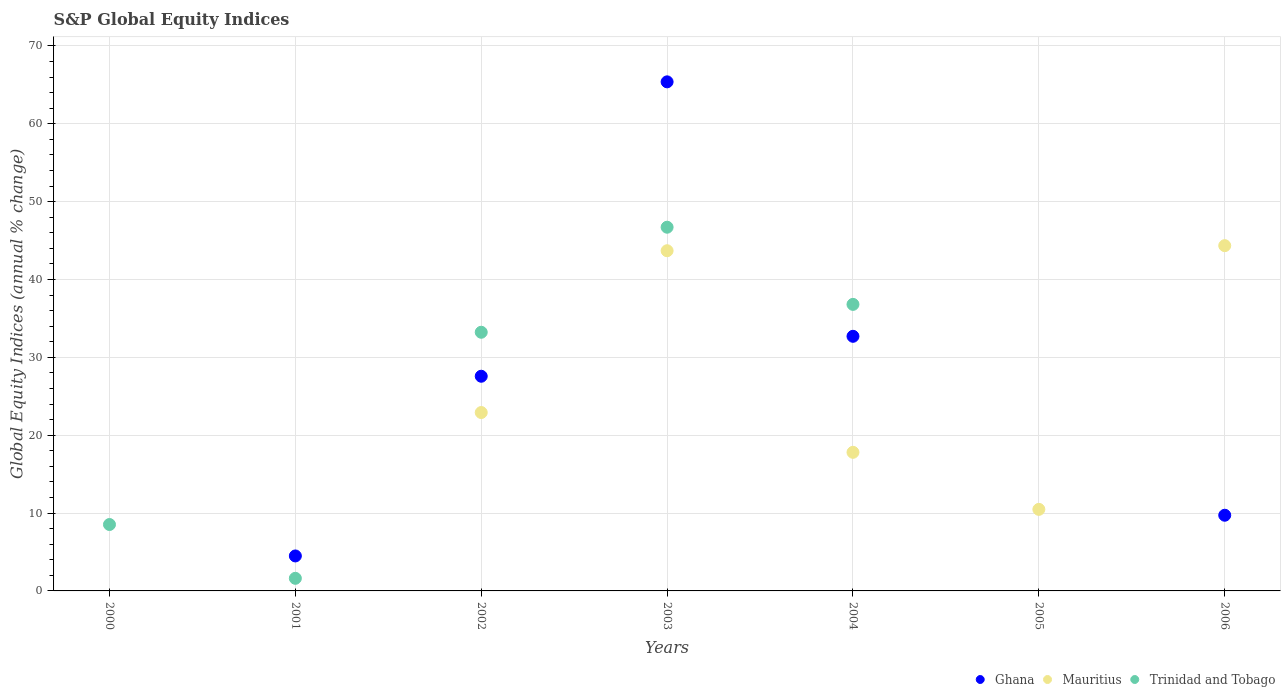Is the number of dotlines equal to the number of legend labels?
Provide a succinct answer. No. What is the global equity indices in Mauritius in 2005?
Give a very brief answer. 10.47. Across all years, what is the maximum global equity indices in Trinidad and Tobago?
Keep it short and to the point. 46.71. What is the total global equity indices in Mauritius in the graph?
Offer a terse response. 139.22. What is the difference between the global equity indices in Ghana in 2004 and that in 2006?
Offer a terse response. 22.98. What is the difference between the global equity indices in Ghana in 2003 and the global equity indices in Mauritius in 2000?
Give a very brief answer. 65.38. What is the average global equity indices in Ghana per year?
Ensure brevity in your answer.  19.98. In the year 2004, what is the difference between the global equity indices in Ghana and global equity indices in Mauritius?
Your answer should be compact. 14.9. In how many years, is the global equity indices in Trinidad and Tobago greater than 52 %?
Offer a very short reply. 0. What is the ratio of the global equity indices in Ghana in 2004 to that in 2006?
Your answer should be compact. 3.36. Is the global equity indices in Ghana in 2002 less than that in 2003?
Your answer should be very brief. Yes. What is the difference between the highest and the second highest global equity indices in Ghana?
Ensure brevity in your answer.  32.68. What is the difference between the highest and the lowest global equity indices in Mauritius?
Provide a succinct answer. 44.34. In how many years, is the global equity indices in Trinidad and Tobago greater than the average global equity indices in Trinidad and Tobago taken over all years?
Make the answer very short. 3. Is the global equity indices in Ghana strictly less than the global equity indices in Trinidad and Tobago over the years?
Provide a succinct answer. No. How many dotlines are there?
Keep it short and to the point. 3. How many years are there in the graph?
Your response must be concise. 7. Does the graph contain any zero values?
Provide a short and direct response. Yes. Does the graph contain grids?
Your answer should be very brief. Yes. Where does the legend appear in the graph?
Your answer should be compact. Bottom right. How many legend labels are there?
Keep it short and to the point. 3. What is the title of the graph?
Ensure brevity in your answer.  S&P Global Equity Indices. Does "Bosnia and Herzegovina" appear as one of the legend labels in the graph?
Your response must be concise. No. What is the label or title of the X-axis?
Ensure brevity in your answer.  Years. What is the label or title of the Y-axis?
Your answer should be compact. Global Equity Indices (annual % change). What is the Global Equity Indices (annual % change) of Ghana in 2000?
Your answer should be very brief. 0. What is the Global Equity Indices (annual % change) in Trinidad and Tobago in 2000?
Provide a short and direct response. 8.53. What is the Global Equity Indices (annual % change) of Ghana in 2001?
Keep it short and to the point. 4.49. What is the Global Equity Indices (annual % change) of Trinidad and Tobago in 2001?
Make the answer very short. 1.62. What is the Global Equity Indices (annual % change) in Ghana in 2002?
Give a very brief answer. 27.57. What is the Global Equity Indices (annual % change) in Mauritius in 2002?
Give a very brief answer. 22.91. What is the Global Equity Indices (annual % change) in Trinidad and Tobago in 2002?
Offer a terse response. 33.22. What is the Global Equity Indices (annual % change) of Ghana in 2003?
Provide a short and direct response. 65.38. What is the Global Equity Indices (annual % change) in Mauritius in 2003?
Offer a terse response. 43.69. What is the Global Equity Indices (annual % change) in Trinidad and Tobago in 2003?
Offer a very short reply. 46.71. What is the Global Equity Indices (annual % change) in Ghana in 2004?
Your answer should be very brief. 32.7. What is the Global Equity Indices (annual % change) in Mauritius in 2004?
Your answer should be very brief. 17.8. What is the Global Equity Indices (annual % change) in Trinidad and Tobago in 2004?
Provide a succinct answer. 36.8. What is the Global Equity Indices (annual % change) in Mauritius in 2005?
Ensure brevity in your answer.  10.47. What is the Global Equity Indices (annual % change) in Ghana in 2006?
Give a very brief answer. 9.72. What is the Global Equity Indices (annual % change) of Mauritius in 2006?
Offer a terse response. 44.34. What is the Global Equity Indices (annual % change) in Trinidad and Tobago in 2006?
Keep it short and to the point. 0. Across all years, what is the maximum Global Equity Indices (annual % change) in Ghana?
Your answer should be compact. 65.38. Across all years, what is the maximum Global Equity Indices (annual % change) in Mauritius?
Provide a short and direct response. 44.34. Across all years, what is the maximum Global Equity Indices (annual % change) in Trinidad and Tobago?
Your answer should be very brief. 46.71. Across all years, what is the minimum Global Equity Indices (annual % change) of Ghana?
Your answer should be very brief. 0. What is the total Global Equity Indices (annual % change) of Ghana in the graph?
Your answer should be very brief. 139.86. What is the total Global Equity Indices (annual % change) of Mauritius in the graph?
Offer a terse response. 139.22. What is the total Global Equity Indices (annual % change) in Trinidad and Tobago in the graph?
Your answer should be very brief. 126.88. What is the difference between the Global Equity Indices (annual % change) of Trinidad and Tobago in 2000 and that in 2001?
Give a very brief answer. 6.91. What is the difference between the Global Equity Indices (annual % change) in Trinidad and Tobago in 2000 and that in 2002?
Make the answer very short. -24.69. What is the difference between the Global Equity Indices (annual % change) in Trinidad and Tobago in 2000 and that in 2003?
Keep it short and to the point. -38.18. What is the difference between the Global Equity Indices (annual % change) in Trinidad and Tobago in 2000 and that in 2004?
Give a very brief answer. -28.27. What is the difference between the Global Equity Indices (annual % change) of Ghana in 2001 and that in 2002?
Ensure brevity in your answer.  -23.08. What is the difference between the Global Equity Indices (annual % change) of Trinidad and Tobago in 2001 and that in 2002?
Offer a terse response. -31.6. What is the difference between the Global Equity Indices (annual % change) of Ghana in 2001 and that in 2003?
Give a very brief answer. -60.89. What is the difference between the Global Equity Indices (annual % change) in Trinidad and Tobago in 2001 and that in 2003?
Offer a terse response. -45.09. What is the difference between the Global Equity Indices (annual % change) of Ghana in 2001 and that in 2004?
Ensure brevity in your answer.  -28.21. What is the difference between the Global Equity Indices (annual % change) in Trinidad and Tobago in 2001 and that in 2004?
Your answer should be compact. -35.18. What is the difference between the Global Equity Indices (annual % change) in Ghana in 2001 and that in 2006?
Offer a very short reply. -5.23. What is the difference between the Global Equity Indices (annual % change) of Ghana in 2002 and that in 2003?
Provide a succinct answer. -37.81. What is the difference between the Global Equity Indices (annual % change) in Mauritius in 2002 and that in 2003?
Give a very brief answer. -20.78. What is the difference between the Global Equity Indices (annual % change) of Trinidad and Tobago in 2002 and that in 2003?
Provide a short and direct response. -13.49. What is the difference between the Global Equity Indices (annual % change) of Ghana in 2002 and that in 2004?
Make the answer very short. -5.13. What is the difference between the Global Equity Indices (annual % change) of Mauritius in 2002 and that in 2004?
Your answer should be compact. 5.11. What is the difference between the Global Equity Indices (annual % change) of Trinidad and Tobago in 2002 and that in 2004?
Provide a succinct answer. -3.58. What is the difference between the Global Equity Indices (annual % change) of Mauritius in 2002 and that in 2005?
Your response must be concise. 12.44. What is the difference between the Global Equity Indices (annual % change) of Ghana in 2002 and that in 2006?
Your response must be concise. 17.85. What is the difference between the Global Equity Indices (annual % change) of Mauritius in 2002 and that in 2006?
Provide a succinct answer. -21.43. What is the difference between the Global Equity Indices (annual % change) in Ghana in 2003 and that in 2004?
Your answer should be compact. 32.68. What is the difference between the Global Equity Indices (annual % change) of Mauritius in 2003 and that in 2004?
Your answer should be very brief. 25.89. What is the difference between the Global Equity Indices (annual % change) in Trinidad and Tobago in 2003 and that in 2004?
Your response must be concise. 9.91. What is the difference between the Global Equity Indices (annual % change) in Mauritius in 2003 and that in 2005?
Your response must be concise. 33.22. What is the difference between the Global Equity Indices (annual % change) in Ghana in 2003 and that in 2006?
Offer a very short reply. 55.66. What is the difference between the Global Equity Indices (annual % change) of Mauritius in 2003 and that in 2006?
Provide a short and direct response. -0.65. What is the difference between the Global Equity Indices (annual % change) of Mauritius in 2004 and that in 2005?
Your answer should be compact. 7.33. What is the difference between the Global Equity Indices (annual % change) of Ghana in 2004 and that in 2006?
Provide a short and direct response. 22.98. What is the difference between the Global Equity Indices (annual % change) of Mauritius in 2004 and that in 2006?
Provide a short and direct response. -26.54. What is the difference between the Global Equity Indices (annual % change) of Mauritius in 2005 and that in 2006?
Offer a very short reply. -33.87. What is the difference between the Global Equity Indices (annual % change) of Ghana in 2001 and the Global Equity Indices (annual % change) of Mauritius in 2002?
Your answer should be compact. -18.42. What is the difference between the Global Equity Indices (annual % change) in Ghana in 2001 and the Global Equity Indices (annual % change) in Trinidad and Tobago in 2002?
Offer a terse response. -28.73. What is the difference between the Global Equity Indices (annual % change) in Ghana in 2001 and the Global Equity Indices (annual % change) in Mauritius in 2003?
Make the answer very short. -39.2. What is the difference between the Global Equity Indices (annual % change) of Ghana in 2001 and the Global Equity Indices (annual % change) of Trinidad and Tobago in 2003?
Your answer should be very brief. -42.22. What is the difference between the Global Equity Indices (annual % change) in Ghana in 2001 and the Global Equity Indices (annual % change) in Mauritius in 2004?
Your answer should be compact. -13.31. What is the difference between the Global Equity Indices (annual % change) of Ghana in 2001 and the Global Equity Indices (annual % change) of Trinidad and Tobago in 2004?
Your response must be concise. -32.31. What is the difference between the Global Equity Indices (annual % change) of Ghana in 2001 and the Global Equity Indices (annual % change) of Mauritius in 2005?
Give a very brief answer. -5.98. What is the difference between the Global Equity Indices (annual % change) in Ghana in 2001 and the Global Equity Indices (annual % change) in Mauritius in 2006?
Your response must be concise. -39.85. What is the difference between the Global Equity Indices (annual % change) of Ghana in 2002 and the Global Equity Indices (annual % change) of Mauritius in 2003?
Keep it short and to the point. -16.12. What is the difference between the Global Equity Indices (annual % change) in Ghana in 2002 and the Global Equity Indices (annual % change) in Trinidad and Tobago in 2003?
Make the answer very short. -19.14. What is the difference between the Global Equity Indices (annual % change) in Mauritius in 2002 and the Global Equity Indices (annual % change) in Trinidad and Tobago in 2003?
Your response must be concise. -23.8. What is the difference between the Global Equity Indices (annual % change) of Ghana in 2002 and the Global Equity Indices (annual % change) of Mauritius in 2004?
Give a very brief answer. 9.77. What is the difference between the Global Equity Indices (annual % change) in Ghana in 2002 and the Global Equity Indices (annual % change) in Trinidad and Tobago in 2004?
Provide a short and direct response. -9.23. What is the difference between the Global Equity Indices (annual % change) of Mauritius in 2002 and the Global Equity Indices (annual % change) of Trinidad and Tobago in 2004?
Make the answer very short. -13.89. What is the difference between the Global Equity Indices (annual % change) of Ghana in 2002 and the Global Equity Indices (annual % change) of Mauritius in 2005?
Your response must be concise. 17.1. What is the difference between the Global Equity Indices (annual % change) of Ghana in 2002 and the Global Equity Indices (annual % change) of Mauritius in 2006?
Offer a terse response. -16.77. What is the difference between the Global Equity Indices (annual % change) of Ghana in 2003 and the Global Equity Indices (annual % change) of Mauritius in 2004?
Give a very brief answer. 47.58. What is the difference between the Global Equity Indices (annual % change) in Ghana in 2003 and the Global Equity Indices (annual % change) in Trinidad and Tobago in 2004?
Provide a short and direct response. 28.58. What is the difference between the Global Equity Indices (annual % change) in Mauritius in 2003 and the Global Equity Indices (annual % change) in Trinidad and Tobago in 2004?
Your answer should be compact. 6.89. What is the difference between the Global Equity Indices (annual % change) in Ghana in 2003 and the Global Equity Indices (annual % change) in Mauritius in 2005?
Keep it short and to the point. 54.91. What is the difference between the Global Equity Indices (annual % change) in Ghana in 2003 and the Global Equity Indices (annual % change) in Mauritius in 2006?
Your answer should be very brief. 21.04. What is the difference between the Global Equity Indices (annual % change) in Ghana in 2004 and the Global Equity Indices (annual % change) in Mauritius in 2005?
Provide a succinct answer. 22.23. What is the difference between the Global Equity Indices (annual % change) in Ghana in 2004 and the Global Equity Indices (annual % change) in Mauritius in 2006?
Make the answer very short. -11.64. What is the average Global Equity Indices (annual % change) of Ghana per year?
Ensure brevity in your answer.  19.98. What is the average Global Equity Indices (annual % change) in Mauritius per year?
Provide a succinct answer. 19.89. What is the average Global Equity Indices (annual % change) in Trinidad and Tobago per year?
Make the answer very short. 18.13. In the year 2001, what is the difference between the Global Equity Indices (annual % change) in Ghana and Global Equity Indices (annual % change) in Trinidad and Tobago?
Your answer should be compact. 2.87. In the year 2002, what is the difference between the Global Equity Indices (annual % change) of Ghana and Global Equity Indices (annual % change) of Mauritius?
Provide a short and direct response. 4.66. In the year 2002, what is the difference between the Global Equity Indices (annual % change) of Ghana and Global Equity Indices (annual % change) of Trinidad and Tobago?
Your answer should be compact. -5.65. In the year 2002, what is the difference between the Global Equity Indices (annual % change) in Mauritius and Global Equity Indices (annual % change) in Trinidad and Tobago?
Offer a very short reply. -10.31. In the year 2003, what is the difference between the Global Equity Indices (annual % change) of Ghana and Global Equity Indices (annual % change) of Mauritius?
Provide a succinct answer. 21.69. In the year 2003, what is the difference between the Global Equity Indices (annual % change) of Ghana and Global Equity Indices (annual % change) of Trinidad and Tobago?
Your answer should be very brief. 18.67. In the year 2003, what is the difference between the Global Equity Indices (annual % change) in Mauritius and Global Equity Indices (annual % change) in Trinidad and Tobago?
Provide a short and direct response. -3.02. In the year 2004, what is the difference between the Global Equity Indices (annual % change) in Ghana and Global Equity Indices (annual % change) in Mauritius?
Provide a succinct answer. 14.9. In the year 2004, what is the difference between the Global Equity Indices (annual % change) of Ghana and Global Equity Indices (annual % change) of Trinidad and Tobago?
Ensure brevity in your answer.  -4.1. In the year 2006, what is the difference between the Global Equity Indices (annual % change) of Ghana and Global Equity Indices (annual % change) of Mauritius?
Your answer should be compact. -34.62. What is the ratio of the Global Equity Indices (annual % change) in Trinidad and Tobago in 2000 to that in 2001?
Offer a very short reply. 5.27. What is the ratio of the Global Equity Indices (annual % change) of Trinidad and Tobago in 2000 to that in 2002?
Offer a terse response. 0.26. What is the ratio of the Global Equity Indices (annual % change) in Trinidad and Tobago in 2000 to that in 2003?
Your answer should be very brief. 0.18. What is the ratio of the Global Equity Indices (annual % change) of Trinidad and Tobago in 2000 to that in 2004?
Provide a succinct answer. 0.23. What is the ratio of the Global Equity Indices (annual % change) of Ghana in 2001 to that in 2002?
Ensure brevity in your answer.  0.16. What is the ratio of the Global Equity Indices (annual % change) in Trinidad and Tobago in 2001 to that in 2002?
Your answer should be very brief. 0.05. What is the ratio of the Global Equity Indices (annual % change) of Ghana in 2001 to that in 2003?
Make the answer very short. 0.07. What is the ratio of the Global Equity Indices (annual % change) in Trinidad and Tobago in 2001 to that in 2003?
Make the answer very short. 0.03. What is the ratio of the Global Equity Indices (annual % change) of Ghana in 2001 to that in 2004?
Give a very brief answer. 0.14. What is the ratio of the Global Equity Indices (annual % change) in Trinidad and Tobago in 2001 to that in 2004?
Give a very brief answer. 0.04. What is the ratio of the Global Equity Indices (annual % change) in Ghana in 2001 to that in 2006?
Offer a very short reply. 0.46. What is the ratio of the Global Equity Indices (annual % change) in Ghana in 2002 to that in 2003?
Offer a very short reply. 0.42. What is the ratio of the Global Equity Indices (annual % change) in Mauritius in 2002 to that in 2003?
Ensure brevity in your answer.  0.52. What is the ratio of the Global Equity Indices (annual % change) in Trinidad and Tobago in 2002 to that in 2003?
Provide a short and direct response. 0.71. What is the ratio of the Global Equity Indices (annual % change) of Ghana in 2002 to that in 2004?
Your answer should be very brief. 0.84. What is the ratio of the Global Equity Indices (annual % change) in Mauritius in 2002 to that in 2004?
Your response must be concise. 1.29. What is the ratio of the Global Equity Indices (annual % change) in Trinidad and Tobago in 2002 to that in 2004?
Make the answer very short. 0.9. What is the ratio of the Global Equity Indices (annual % change) of Mauritius in 2002 to that in 2005?
Your response must be concise. 2.19. What is the ratio of the Global Equity Indices (annual % change) of Ghana in 2002 to that in 2006?
Your answer should be compact. 2.84. What is the ratio of the Global Equity Indices (annual % change) of Mauritius in 2002 to that in 2006?
Offer a very short reply. 0.52. What is the ratio of the Global Equity Indices (annual % change) of Ghana in 2003 to that in 2004?
Your answer should be compact. 2. What is the ratio of the Global Equity Indices (annual % change) in Mauritius in 2003 to that in 2004?
Offer a terse response. 2.45. What is the ratio of the Global Equity Indices (annual % change) of Trinidad and Tobago in 2003 to that in 2004?
Give a very brief answer. 1.27. What is the ratio of the Global Equity Indices (annual % change) of Mauritius in 2003 to that in 2005?
Make the answer very short. 4.17. What is the ratio of the Global Equity Indices (annual % change) of Ghana in 2003 to that in 2006?
Offer a very short reply. 6.73. What is the ratio of the Global Equity Indices (annual % change) in Mauritius in 2004 to that in 2005?
Make the answer very short. 1.7. What is the ratio of the Global Equity Indices (annual % change) of Ghana in 2004 to that in 2006?
Provide a short and direct response. 3.36. What is the ratio of the Global Equity Indices (annual % change) of Mauritius in 2004 to that in 2006?
Your answer should be compact. 0.4. What is the ratio of the Global Equity Indices (annual % change) in Mauritius in 2005 to that in 2006?
Your response must be concise. 0.24. What is the difference between the highest and the second highest Global Equity Indices (annual % change) of Ghana?
Make the answer very short. 32.68. What is the difference between the highest and the second highest Global Equity Indices (annual % change) in Mauritius?
Keep it short and to the point. 0.65. What is the difference between the highest and the second highest Global Equity Indices (annual % change) in Trinidad and Tobago?
Your response must be concise. 9.91. What is the difference between the highest and the lowest Global Equity Indices (annual % change) of Ghana?
Your answer should be compact. 65.38. What is the difference between the highest and the lowest Global Equity Indices (annual % change) of Mauritius?
Offer a very short reply. 44.34. What is the difference between the highest and the lowest Global Equity Indices (annual % change) of Trinidad and Tobago?
Provide a short and direct response. 46.71. 